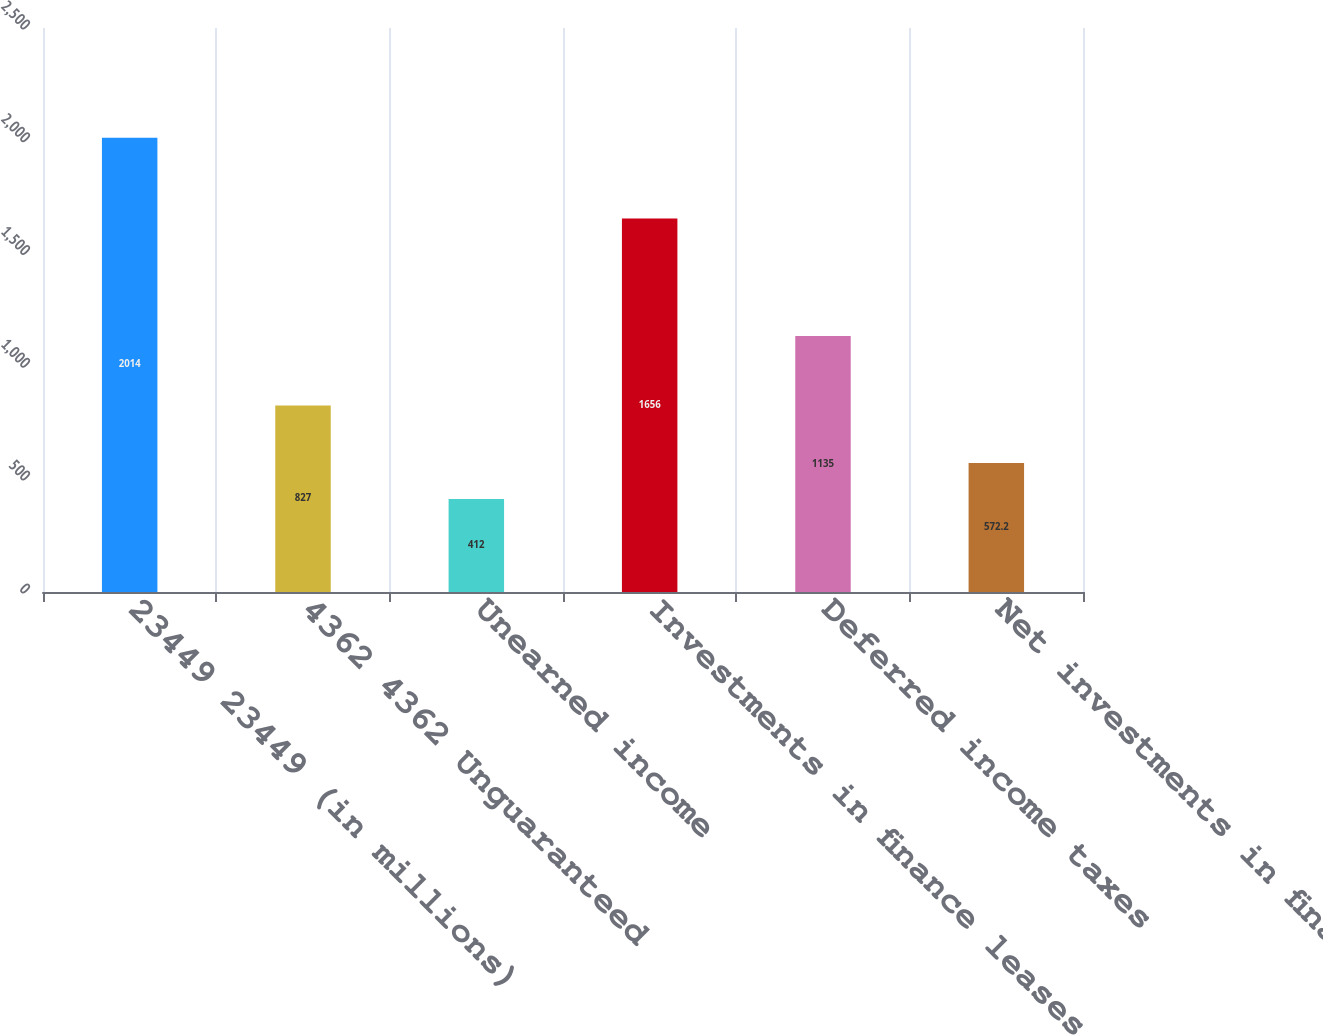<chart> <loc_0><loc_0><loc_500><loc_500><bar_chart><fcel>23449 23449 (in millions)<fcel>4362 4362 Unguaranteed<fcel>Unearned income<fcel>Investments in finance leases<fcel>Deferred income taxes<fcel>Net investments in finance<nl><fcel>2014<fcel>827<fcel>412<fcel>1656<fcel>1135<fcel>572.2<nl></chart> 